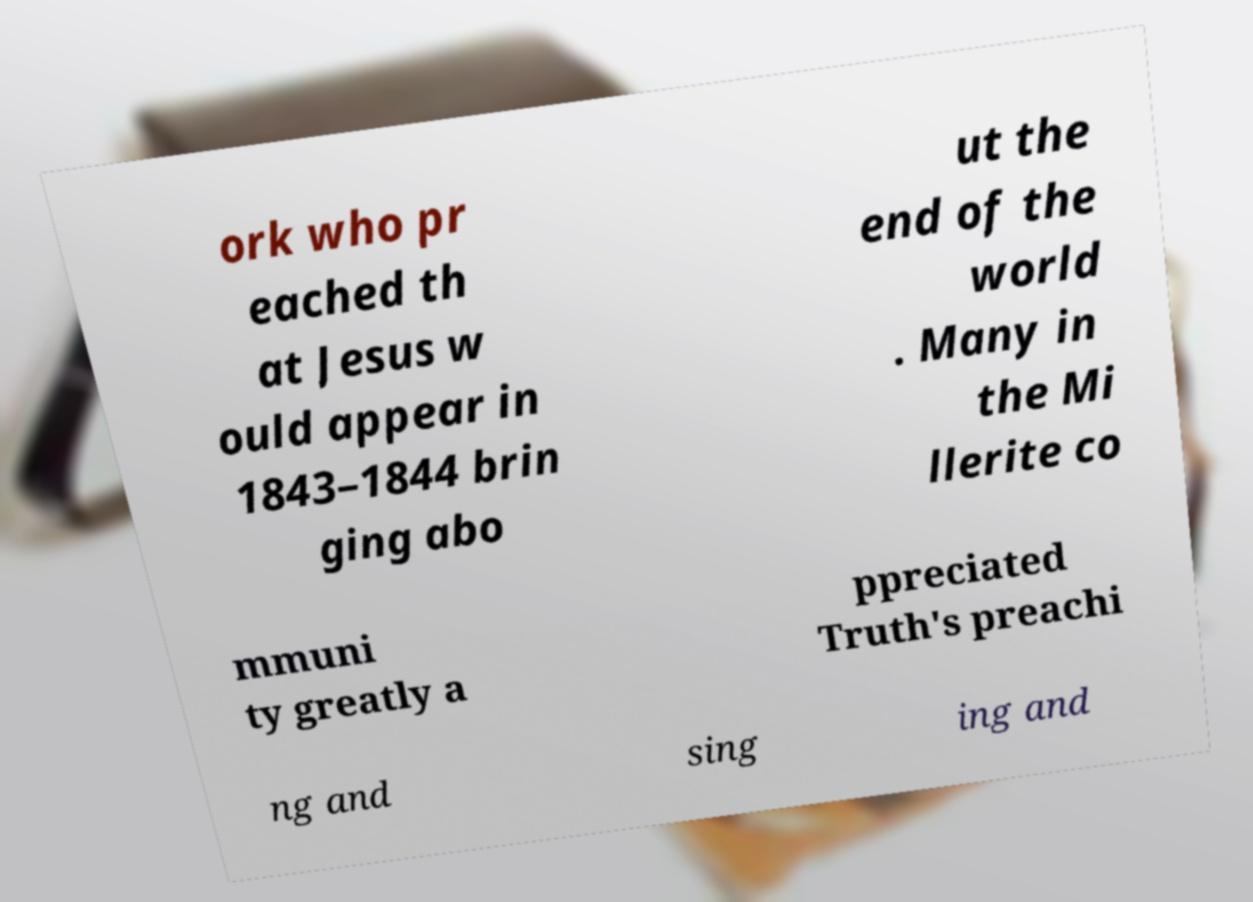Please read and relay the text visible in this image. What does it say? ork who pr eached th at Jesus w ould appear in 1843–1844 brin ging abo ut the end of the world . Many in the Mi llerite co mmuni ty greatly a ppreciated Truth's preachi ng and sing ing and 